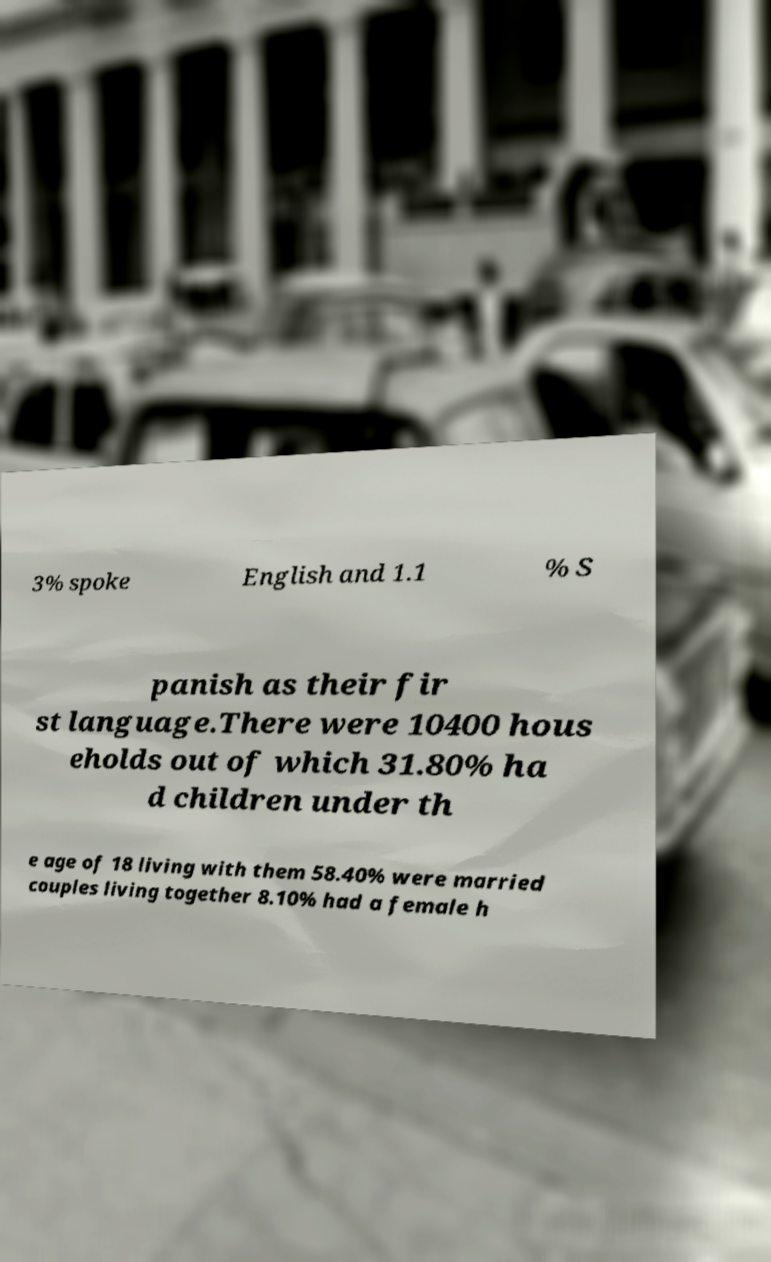Can you accurately transcribe the text from the provided image for me? 3% spoke English and 1.1 % S panish as their fir st language.There were 10400 hous eholds out of which 31.80% ha d children under th e age of 18 living with them 58.40% were married couples living together 8.10% had a female h 